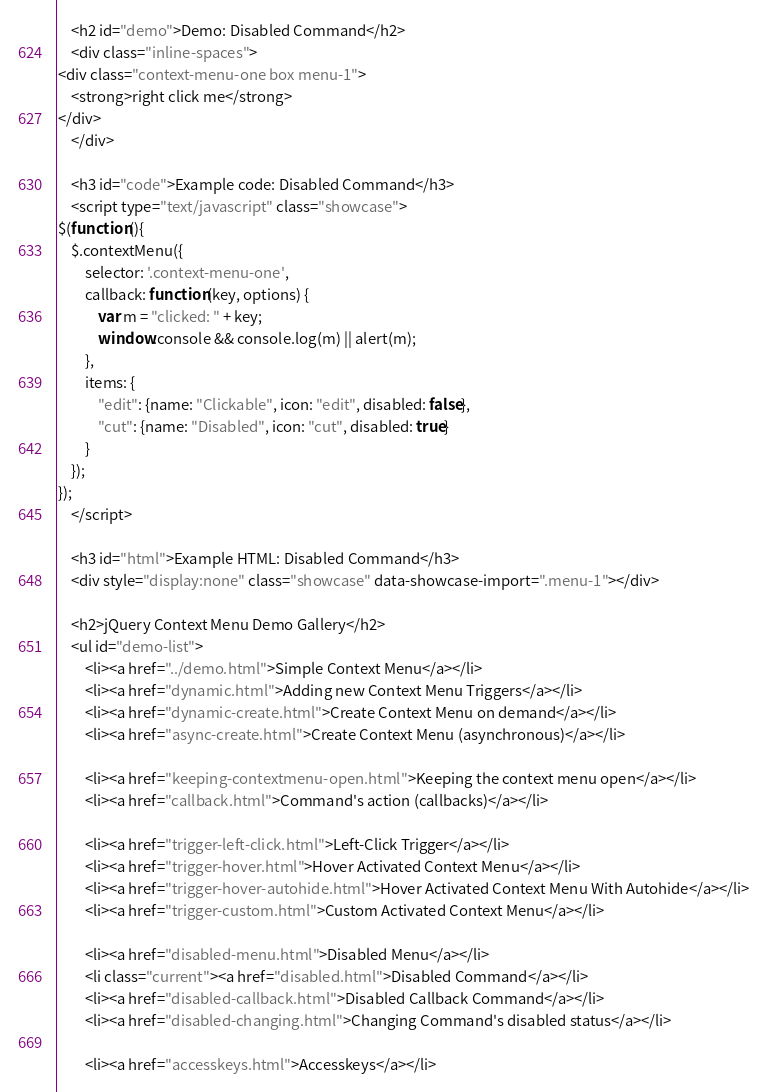Convert code to text. <code><loc_0><loc_0><loc_500><loc_500><_HTML_>    <h2 id="demo">Demo: Disabled Command</h2>
    <div class="inline-spaces">
<div class="context-menu-one box menu-1">
    <strong>right click me</strong>
</div>
    </div>

    <h3 id="code">Example code: Disabled Command</h3>
    <script type="text/javascript" class="showcase">
$(function(){
    $.contextMenu({
        selector: '.context-menu-one', 
        callback: function(key, options) {
            var m = "clicked: " + key;
            window.console && console.log(m) || alert(m); 
        },
        items: {
            "edit": {name: "Clickable", icon: "edit", disabled: false},
            "cut": {name: "Disabled", icon: "cut", disabled: true}
        }
    });
});
    </script>

    <h3 id="html">Example HTML: Disabled Command</h3>
    <div style="display:none" class="showcase" data-showcase-import=".menu-1"></div>
    
    <h2>jQuery Context Menu Demo Gallery</h2>
    <ul id="demo-list">
        <li><a href="../demo.html">Simple Context Menu</a></li>
        <li><a href="dynamic.html">Adding new Context Menu Triggers</a></li>
        <li><a href="dynamic-create.html">Create Context Menu on demand</a></li>
        <li><a href="async-create.html">Create Context Menu (asynchronous)</a></li>

        <li><a href="keeping-contextmenu-open.html">Keeping the context menu open</a></li>
        <li><a href="callback.html">Command's action (callbacks)</a></li>

        <li><a href="trigger-left-click.html">Left-Click Trigger</a></li>
        <li><a href="trigger-hover.html">Hover Activated Context Menu</a></li>
        <li><a href="trigger-hover-autohide.html">Hover Activated Context Menu With Autohide</a></li>
        <li><a href="trigger-custom.html">Custom Activated Context Menu</a></li>

        <li><a href="disabled-menu.html">Disabled Menu</a></li>
        <li class="current"><a href="disabled.html">Disabled Command</a></li>
        <li><a href="disabled-callback.html">Disabled Callback Command</a></li>
        <li><a href="disabled-changing.html">Changing Command's disabled status</a></li>

        <li><a href="accesskeys.html">Accesskeys</a></li></code> 